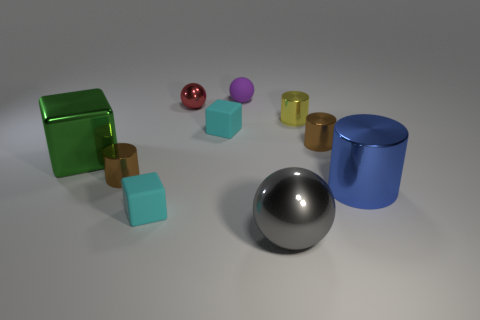Are there any small brown cylinders that have the same material as the small yellow cylinder?
Offer a very short reply. Yes. How many big blue cylinders are there?
Your answer should be compact. 1. How many cylinders are tiny yellow things or large objects?
Keep it short and to the point. 2. There is a sphere that is the same size as the blue object; what color is it?
Your answer should be very brief. Gray. What number of things are both in front of the matte ball and to the right of the large metallic cube?
Your answer should be very brief. 8. What material is the big cylinder?
Provide a succinct answer. Metal. How many things are big shiny spheres or metal balls?
Your answer should be compact. 2. Do the cyan block that is behind the blue metallic thing and the brown thing that is in front of the large green cube have the same size?
Your answer should be very brief. Yes. How many other objects are the same size as the yellow cylinder?
Make the answer very short. 6. How many objects are cyan blocks that are behind the shiny cube or shiny things left of the red thing?
Give a very brief answer. 3. 